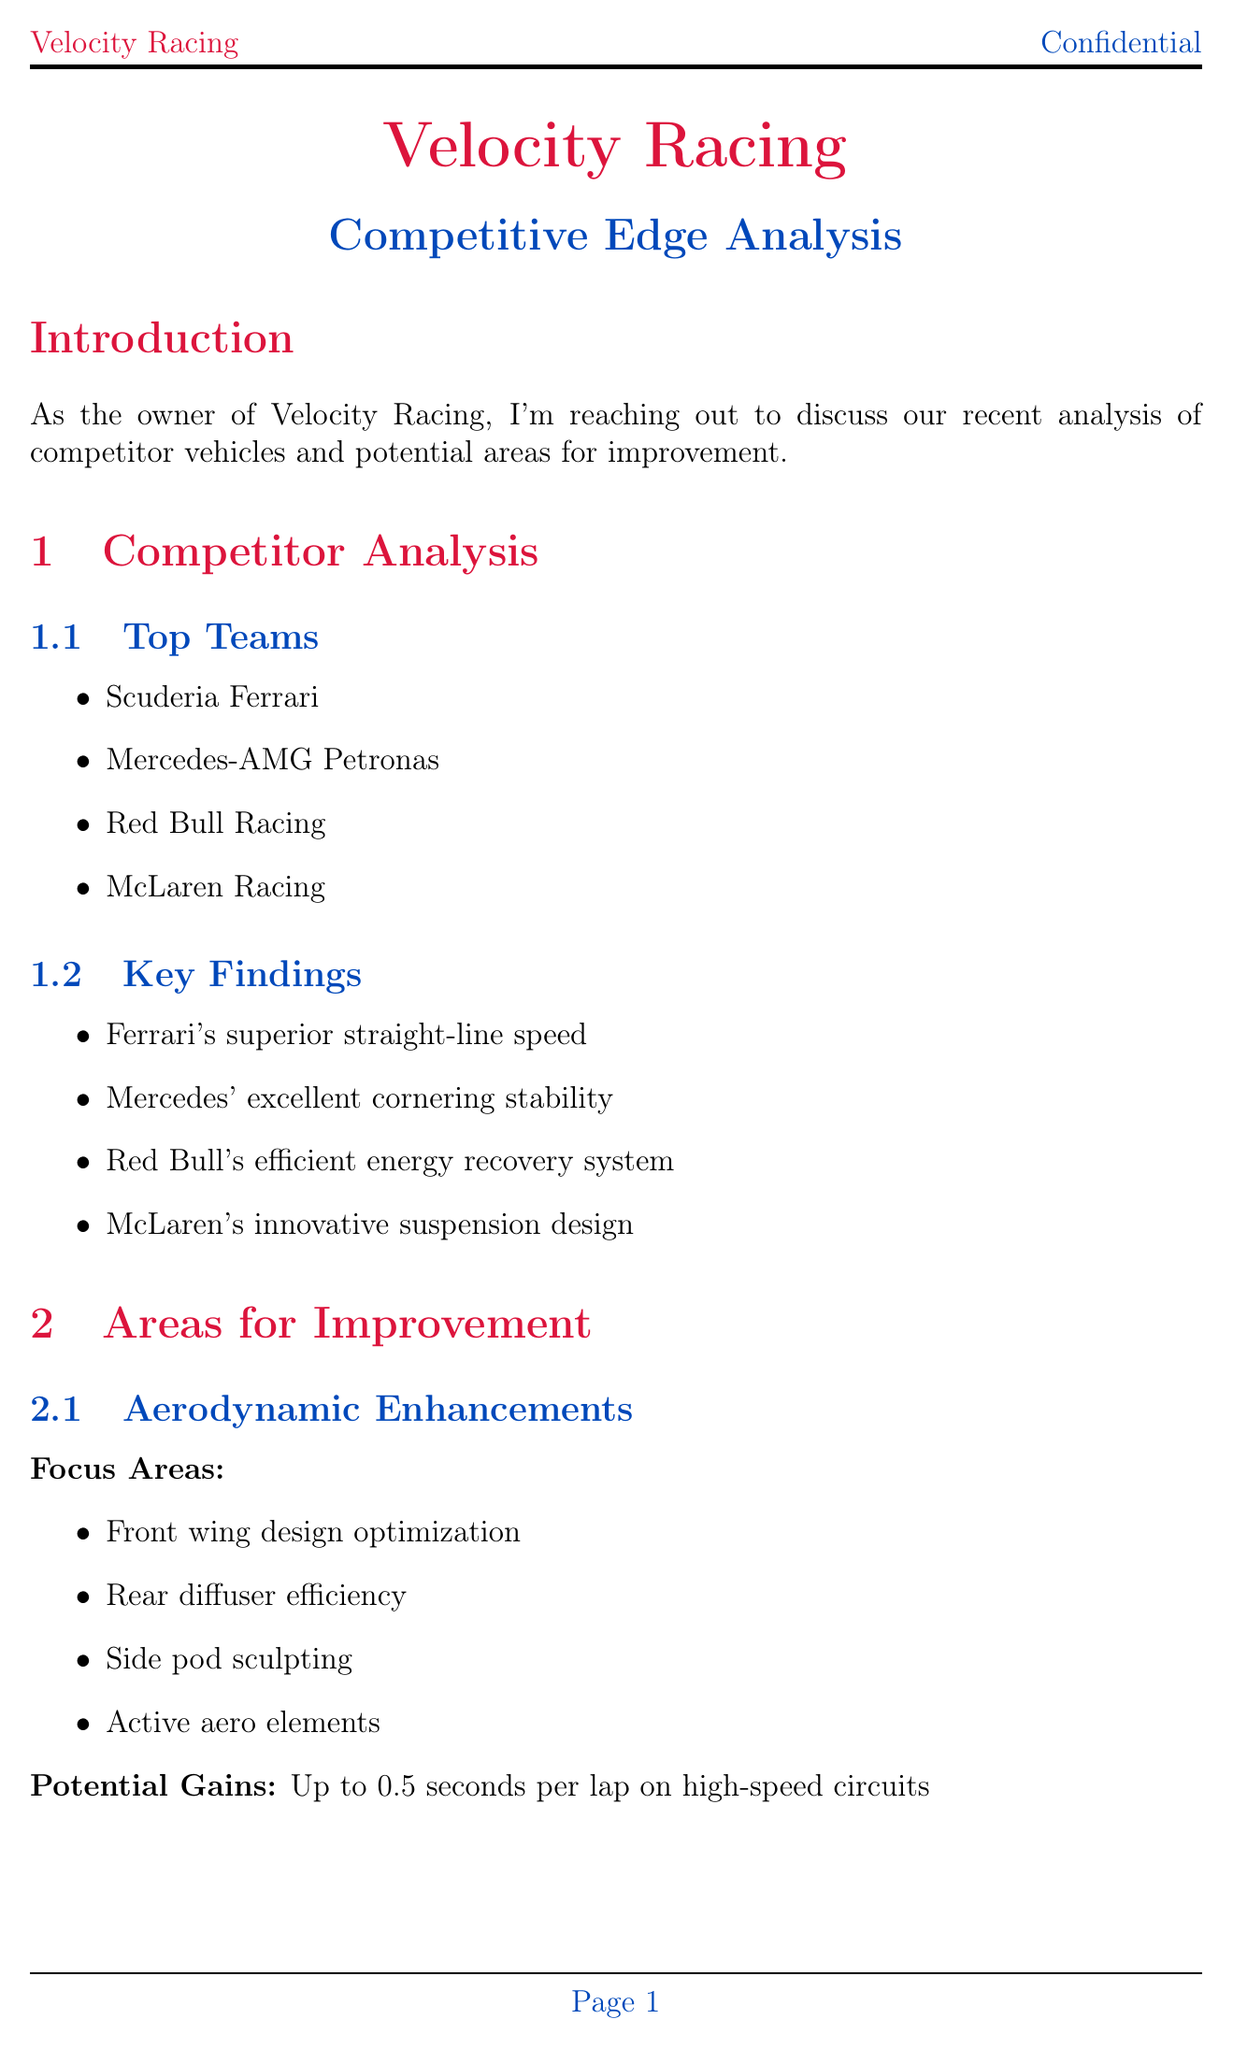What are the top teams mentioned? The document lists the top teams analyzed in the competitor analysis section, which include Scuderia Ferrari, Mercedes-AMG Petronas, Red Bull Racing, and McLaren Racing.
Answer: Scuderia Ferrari, Mercedes-AMG Petronas, Red Bull Racing, McLaren Racing What is the potential gain from aerodynamic enhancements? The potential gains from aerodynamic enhancements are detailed in the document, stating that it can lead to up to 0.5 seconds per lap on high-speed circuits.
Answer: Up to 0.5 seconds per lap What is the expected outcome of engine performance upgrades? The document specifies that the expected outcome from engine performance upgrades is a 3-5% increase in overall power output.
Answer: 3-5% increase What target weight reduction is mentioned in the document? The target for weight reduction strategies is specified as reducing overall vehicle weight by 15-20 kg.
Answer: 15-20 kg Which area of interest is listed under suspension upgrades? The areas of interest for suspension and handling improvements include multiple options, one of which is the adaptive damping system.
Answer: Adaptive damping system What is the goal for tire management? The goal outlined for tire management focuses on extending tire life while maintaining performance, specifically aiming for a 20% extension of tire life.
Answer: Extend tire life by 20% What is the estimated cost for prototyping and testing? The document provides estimated costs for different items, stating that the cost for prototyping and testing is $3 million.
Answer: $3 million What is the target completion timeline for the modifications? The timeline section indicates that the target completion for the modifications is before the start of the next racing season.
Answer: Before the start of the next racing season 